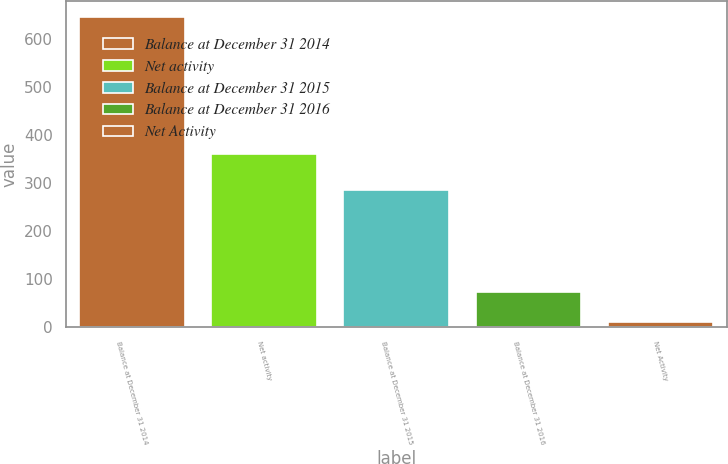Convert chart. <chart><loc_0><loc_0><loc_500><loc_500><bar_chart><fcel>Balance at December 31 2014<fcel>Net activity<fcel>Balance at December 31 2015<fcel>Balance at December 31 2016<fcel>Net Activity<nl><fcel>647<fcel>361<fcel>286<fcel>73.7<fcel>10<nl></chart> 